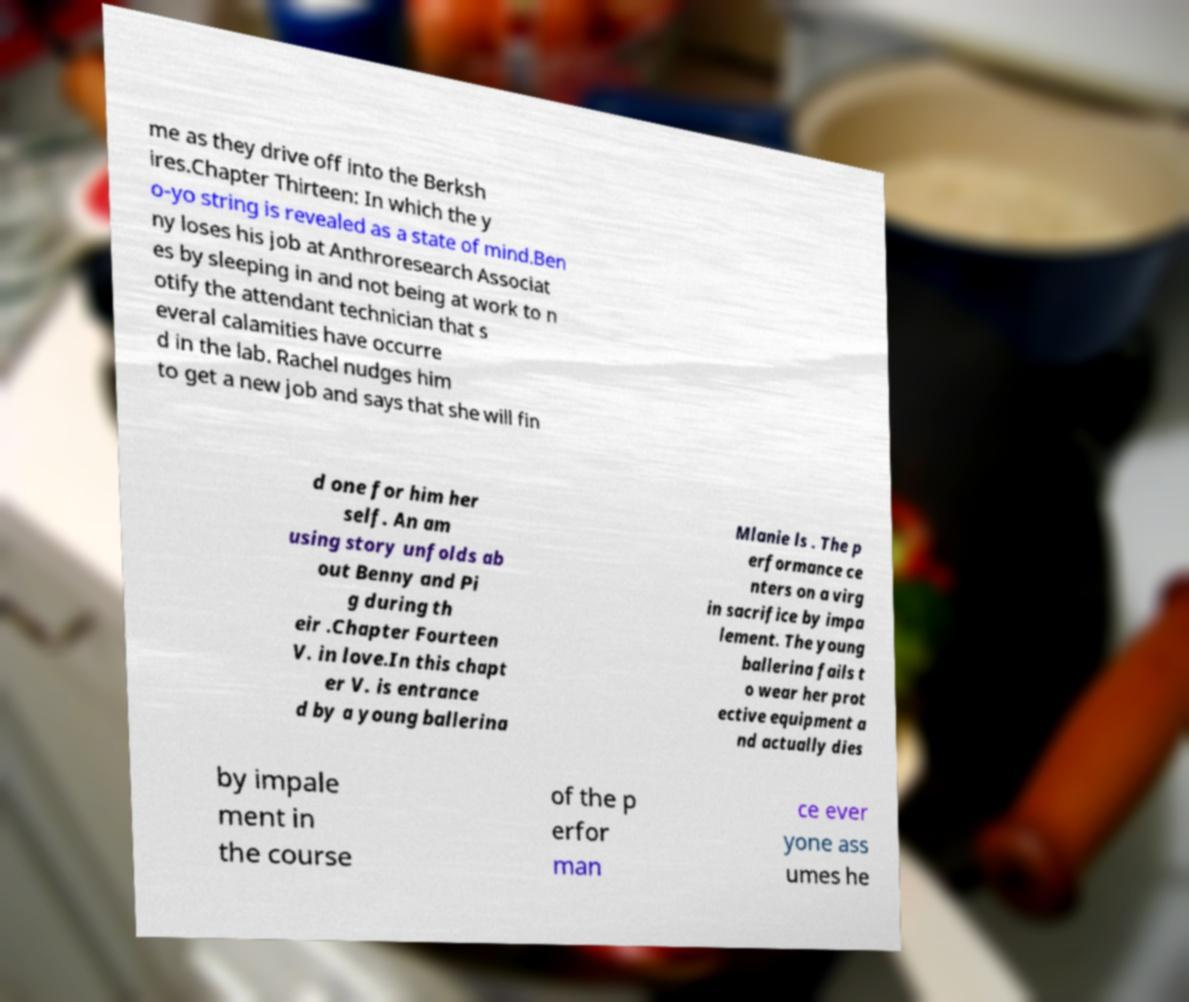There's text embedded in this image that I need extracted. Can you transcribe it verbatim? me as they drive off into the Berksh ires.Chapter Thirteen: In which the y o-yo string is revealed as a state of mind.Ben ny loses his job at Anthroresearch Associat es by sleeping in and not being at work to n otify the attendant technician that s everal calamities have occurre d in the lab. Rachel nudges him to get a new job and says that she will fin d one for him her self. An am using story unfolds ab out Benny and Pi g during th eir .Chapter Fourteen V. in love.In this chapt er V. is entrance d by a young ballerina Mlanie ls . The p erformance ce nters on a virg in sacrifice by impa lement. The young ballerina fails t o wear her prot ective equipment a nd actually dies by impale ment in the course of the p erfor man ce ever yone ass umes he 